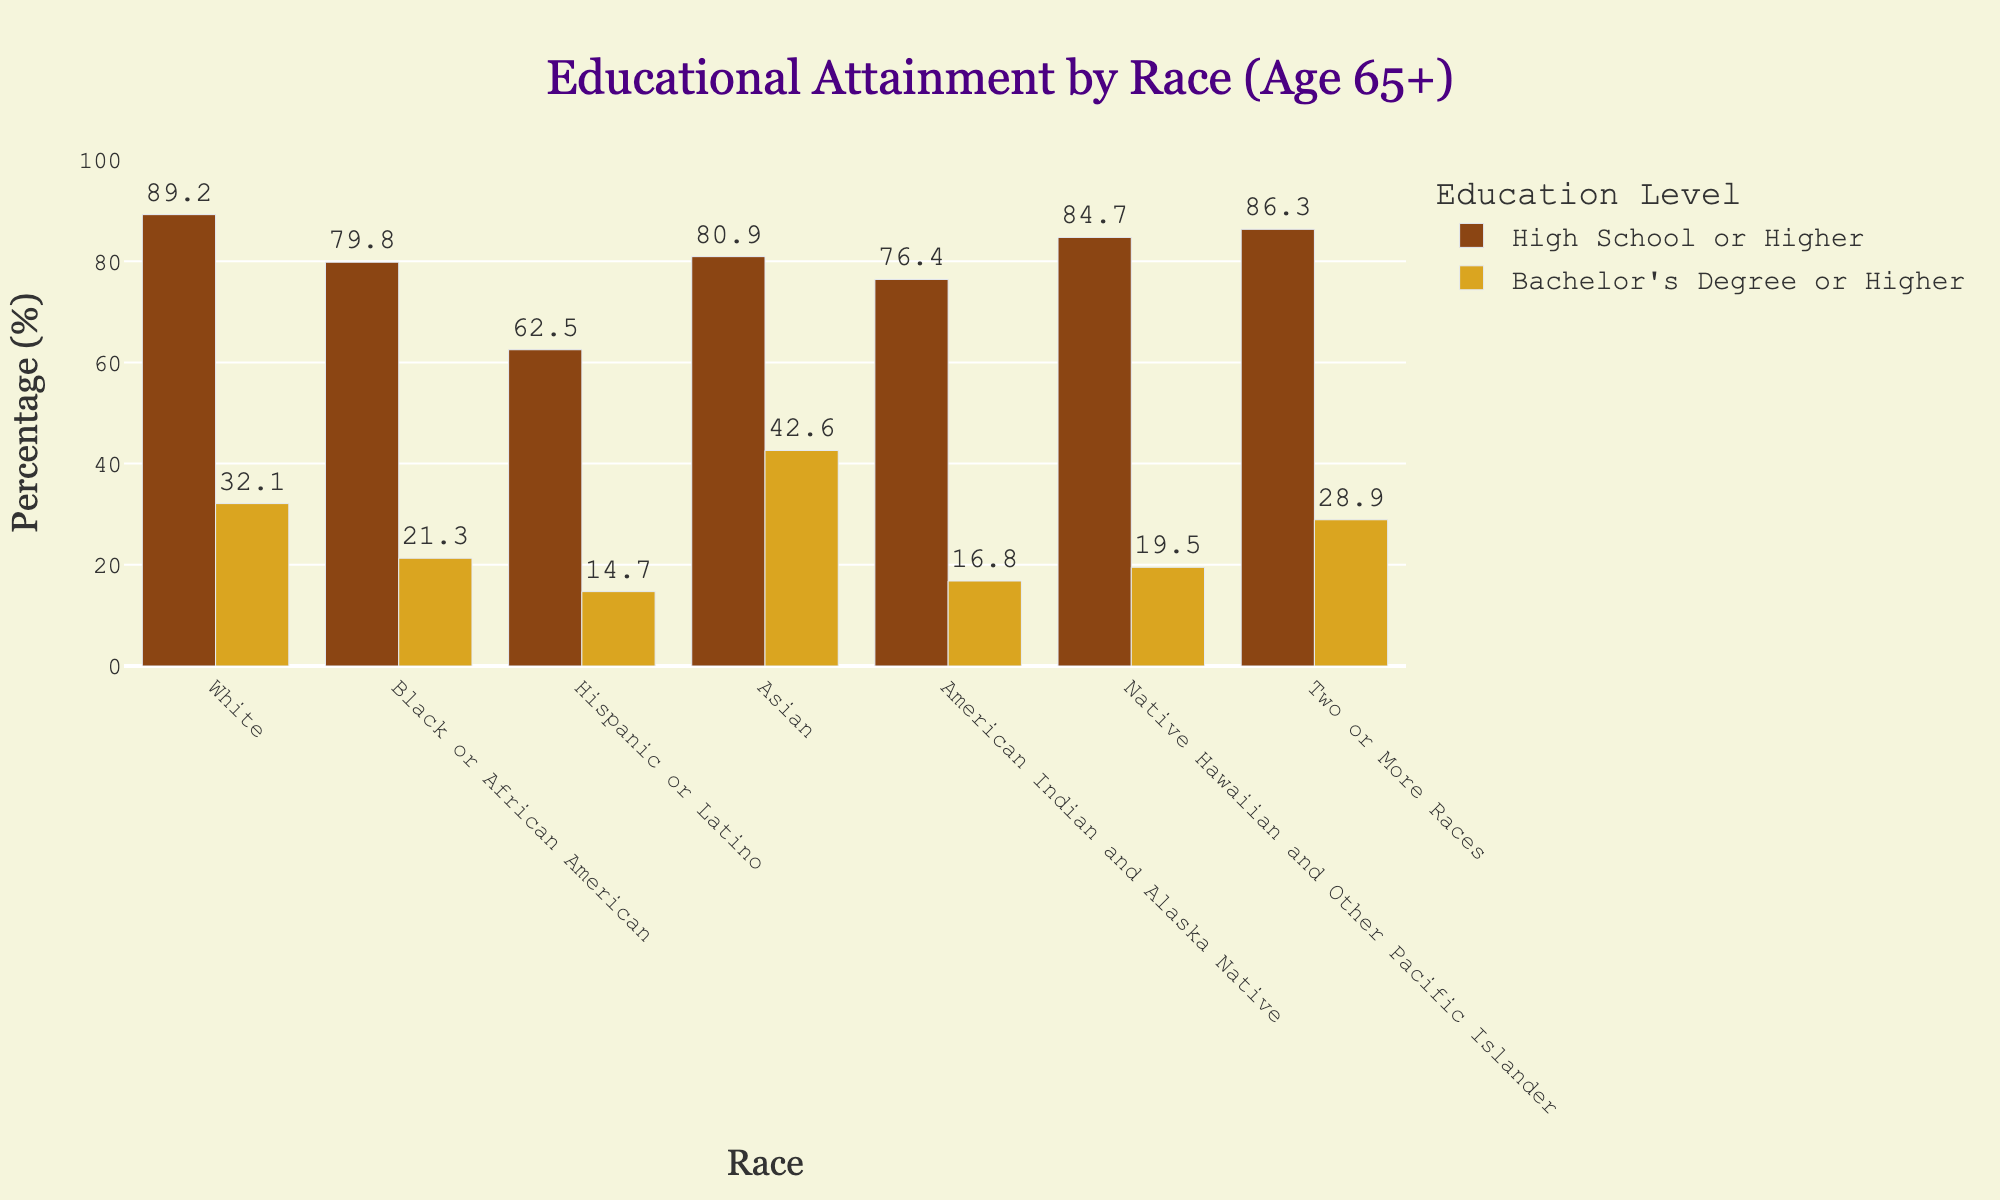Which racial group has the highest percentage of individuals aged 65 and older with a Bachelor’s Degree or Higher? Look at the bar labeled "Bachelor's Degree or Higher" and find the tallest bar. The tallest bar represents the Asian group, with a percentage of 42.6.
Answer: Asian Which group has the lowest percentage of individuals with at least a High School education? Look at the "High School or Higher" bars and identify the shortest bar. The shortest bar represents the Hispanic or Latino group, with a percentage of 62.5.
Answer: Hispanic or Latino What is the percentage difference between Whites and Blacks or African Americans in having a Bachelor's Degree or Higher? Look at the Bachelor's Degree or Higher percentages for Whites and Blacks or African Americans, which are 32.1% and 21.3% respectively. Subtract 21.3 from 32.1 to get 10.8.
Answer: 10.8 How does the percentage of Native Hawaiian and Other Pacific Islander individuals aged 65 and older with at least a High School education compare to that of Black or African American individuals? Compare the "High School or Higher" percentages for Native Hawaiian and Other Pacific Islander (84.7%) and Black or African American (79.8%). Notice that 84.7 is greater than 79.8.
Answer: Native Hawaiian and Other Pacific Islander have a higher percentage than Black or African American Is the percentage of Asians with a Bachelor's Degree or Higher more than double the percentage of Hispanics or Latinos with the same education level? Compare the percentage of Asians with a Bachelor's Degree or Higher (42.6%) to twice the percentage of Hispanics or Latinos with a Bachelor's Degree or Higher (14.7% * 2 = 29.4%). Since 42.6 is greater than 29.4, the answer is yes.
Answer: Yes What is the average percentage of individuals aged 65 and older with at least a High School education across all racial groups? Sum the "High School or Higher" percentages for all racial groups and divide by the number of groups. ((89.2 + 79.8 + 62.5 + 80.9 + 76.4 + 84.7 + 86.3) / 7) = 80.57.
Answer: 80.57 Which racial groups have a higher percentage of individuals aged 65 and older with at least a High School education compared to the average percentage found in the previous question? Compare each group's percentage with the calculated average (80.57%). The groups with percentages higher than 80.57% are White (89.2), Asian (80.9), Native Hawaiian and Other Pacific Islander (84.7), and Two or More Races (86.3).
Answer: White, Asian, Native Hawaiian and Other Pacific Islander, Two or More Races 